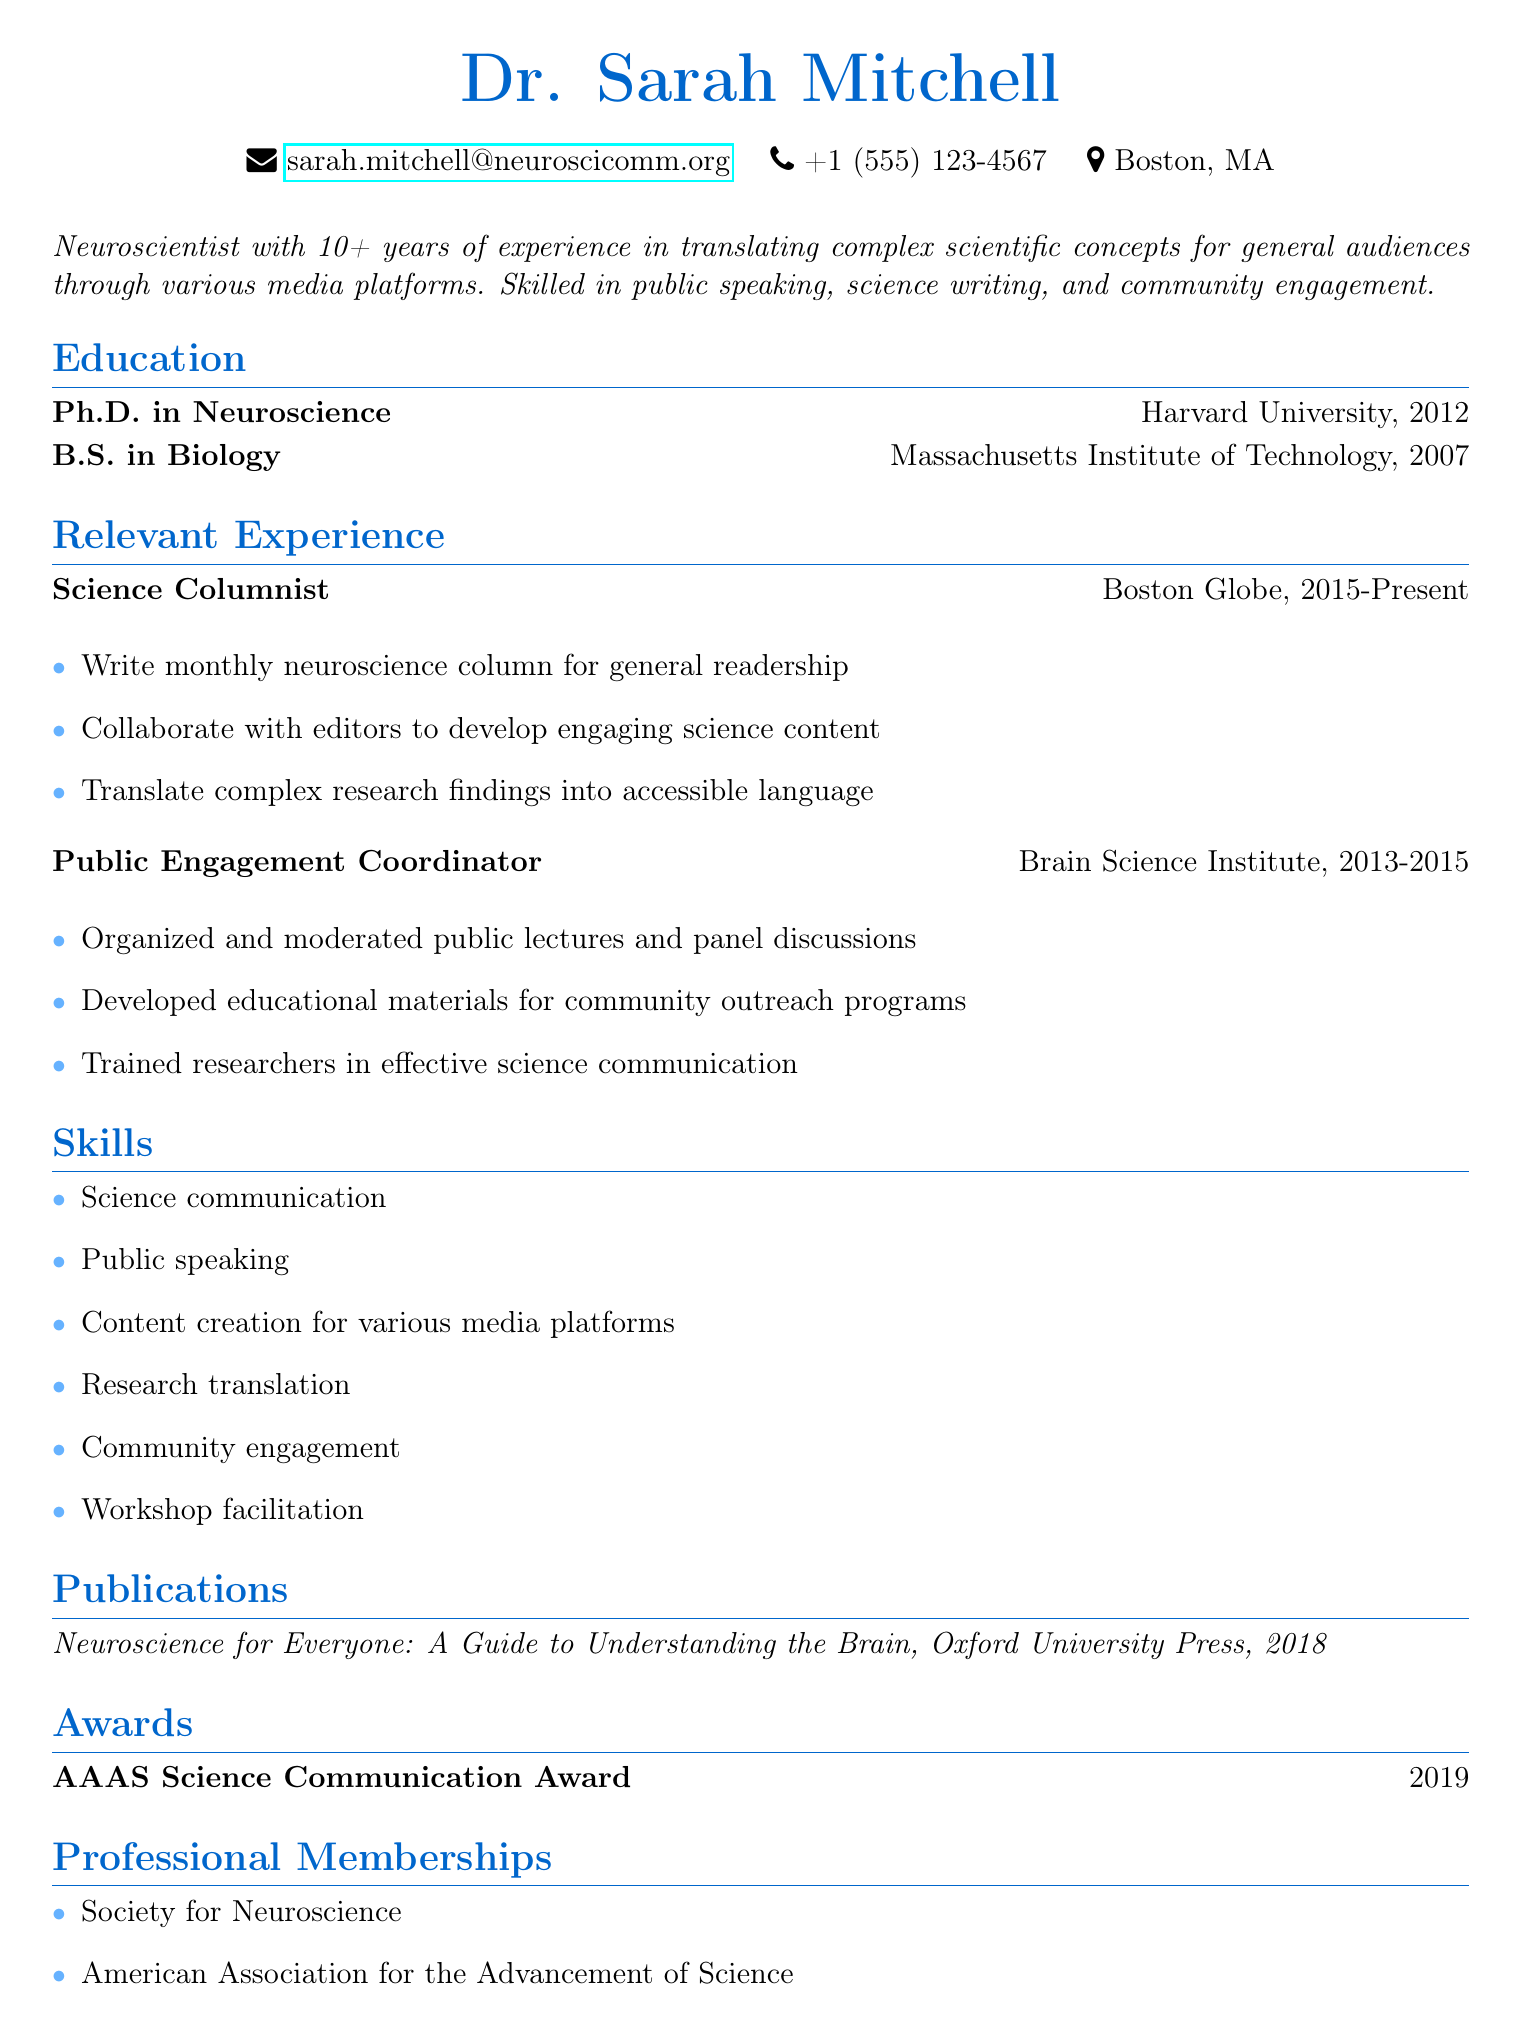What is Dr. Sarah Mitchell's email address? The email address provided in the document is a specific piece of information under personal information.
Answer: sarah.mitchell@neuroscicomm.org What is Dr. Sarah Mitchell's primary area of expertise? The professional summary highlights that Dr. Sarah Mitchell is a neuroscientist.
Answer: Neuroscientist In what year did Dr. Sarah Mitchell receive her Ph.D.? This information is derived from the education section of the document, specifying her degree and the year awarded.
Answer: 2012 What award did Dr. Sarah Mitchell win in 2019? The awards section lists specific recognitions, indicating the name and year of the award.
Answer: AAAS Science Communication Award How many years of experience does Dr. Sarah Mitchell have in science communication? The professional summary mentions "10+ years of experience," indicating her extensive background in the field.
Answer: 10+ What sort of media content does Dr. Sarah Mitchell create? The relevant experience outlines her responsibilities as a science columnist, which involves specific content types.
Answer: Neuroscience column Which organization did Dr. Sarah Mitchell work for as a Public Engagement Coordinator? This detail is directly found in the relevant experience section, showing the organization where she held that title.
Answer: Brain Science Institute What is one of Dr. Sarah Mitchell's skills related to community outreach? The skills section lists this information specifically, demonstrating her expertise in connecting with the community.
Answer: Community engagement What is the title of Dr. Sarah Mitchell’s publication from 2018? The publications section indicates the specific publication title along with the publishing details year.
Answer: Neuroscience for Everyone: A Guide to Understanding the Brain 